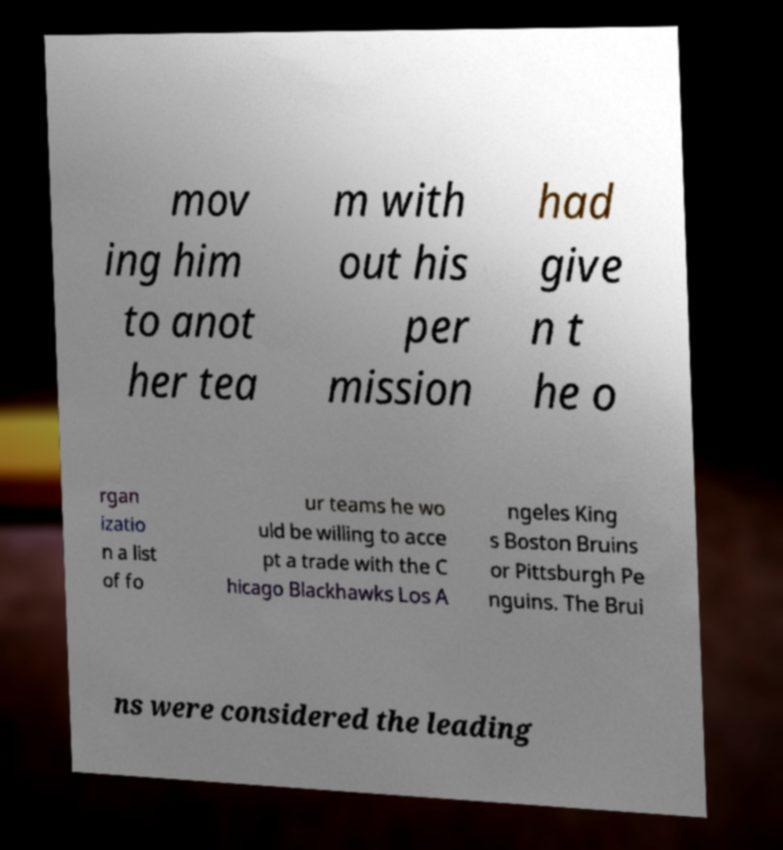Please read and relay the text visible in this image. What does it say? mov ing him to anot her tea m with out his per mission had give n t he o rgan izatio n a list of fo ur teams he wo uld be willing to acce pt a trade with the C hicago Blackhawks Los A ngeles King s Boston Bruins or Pittsburgh Pe nguins. The Brui ns were considered the leading 